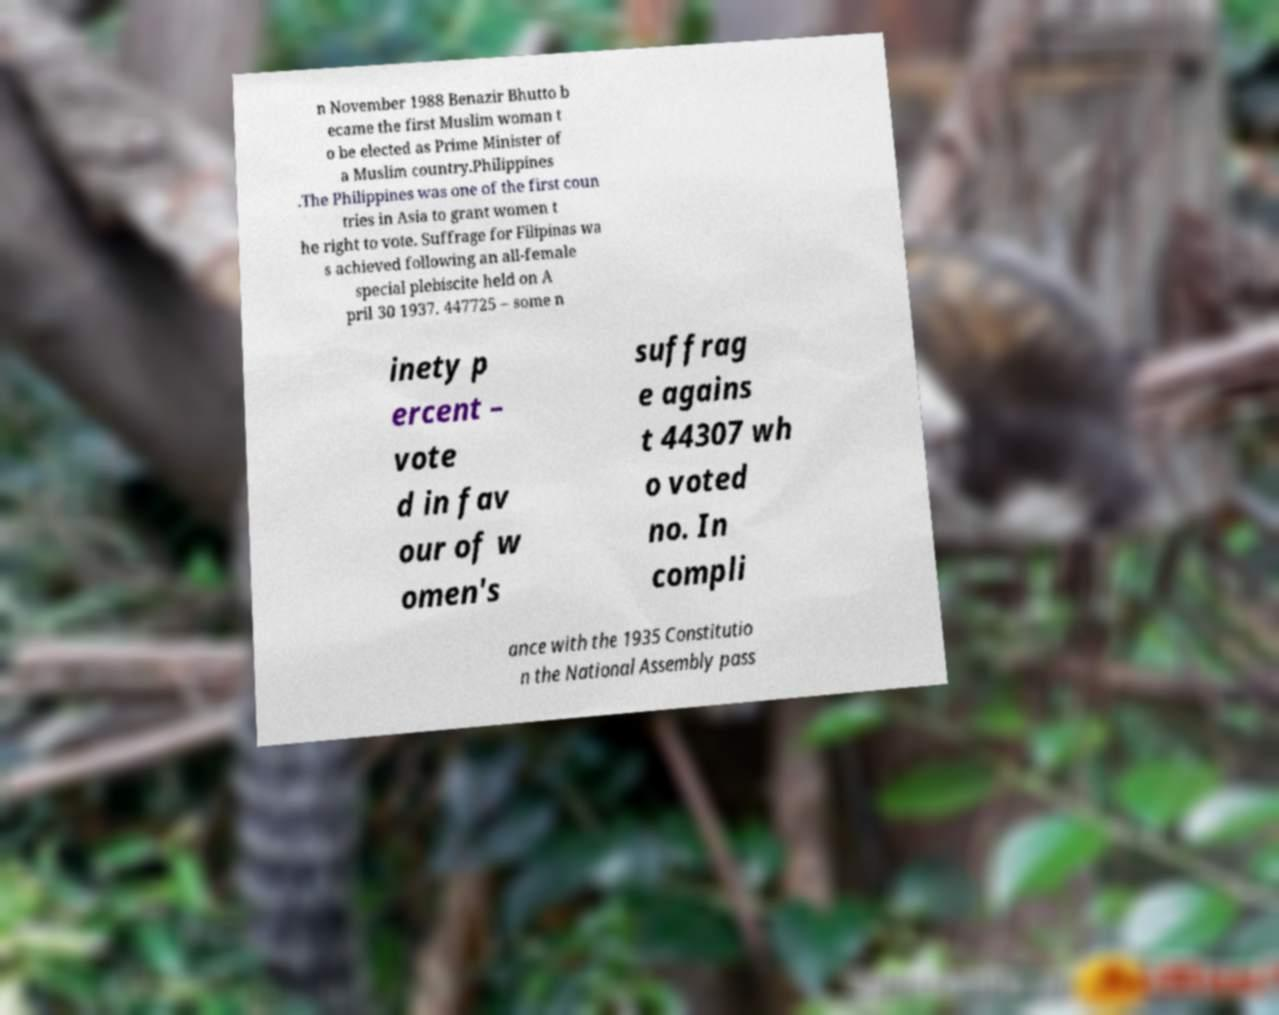What messages or text are displayed in this image? I need them in a readable, typed format. n November 1988 Benazir Bhutto b ecame the first Muslim woman t o be elected as Prime Minister of a Muslim country.Philippines .The Philippines was one of the first coun tries in Asia to grant women t he right to vote. Suffrage for Filipinas wa s achieved following an all-female special plebiscite held on A pril 30 1937. 447725 – some n inety p ercent – vote d in fav our of w omen's suffrag e agains t 44307 wh o voted no. In compli ance with the 1935 Constitutio n the National Assembly pass 